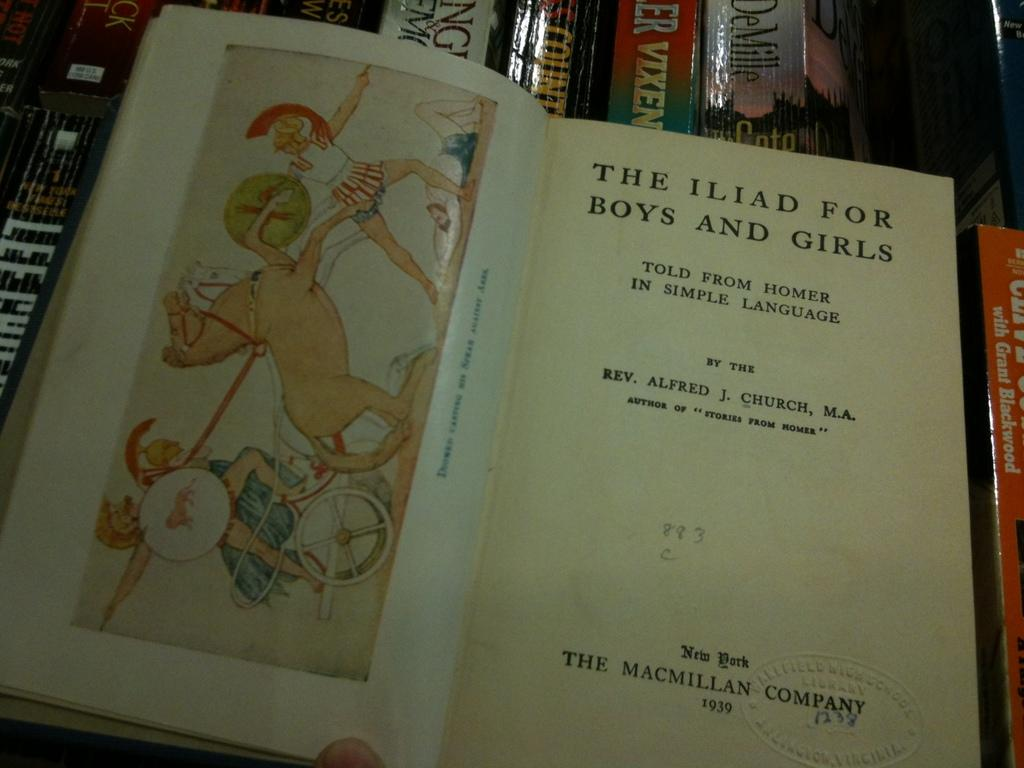<image>
Provide a brief description of the given image. The title of the open book is The Iliad For Boys and Girls 